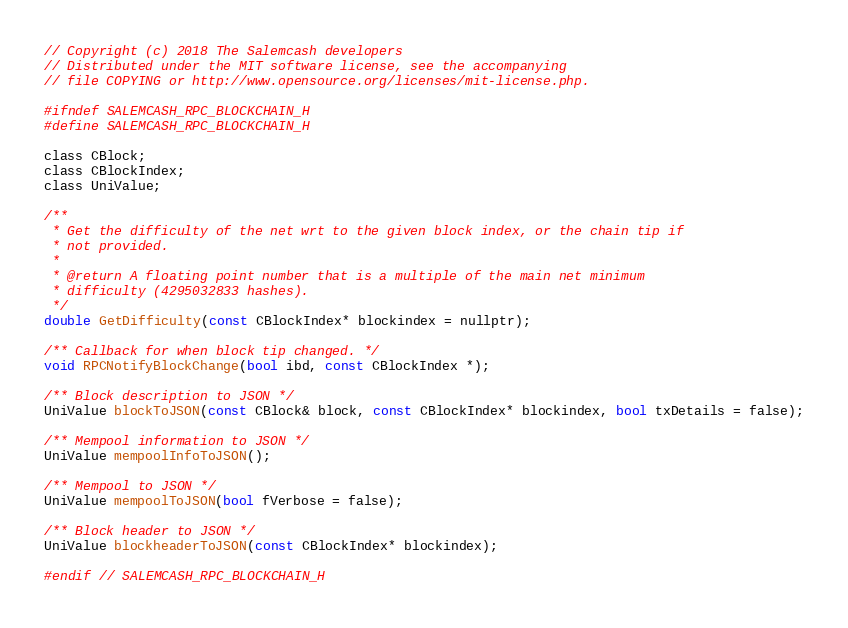Convert code to text. <code><loc_0><loc_0><loc_500><loc_500><_C_>// Copyright (c) 2018 The Salemcash developers
// Distributed under the MIT software license, see the accompanying
// file COPYING or http://www.opensource.org/licenses/mit-license.php.

#ifndef SALEMCASH_RPC_BLOCKCHAIN_H
#define SALEMCASH_RPC_BLOCKCHAIN_H

class CBlock;
class CBlockIndex;
class UniValue;

/**
 * Get the difficulty of the net wrt to the given block index, or the chain tip if
 * not provided.
 *
 * @return A floating point number that is a multiple of the main net minimum
 * difficulty (4295032833 hashes).
 */
double GetDifficulty(const CBlockIndex* blockindex = nullptr);

/** Callback for when block tip changed. */
void RPCNotifyBlockChange(bool ibd, const CBlockIndex *);

/** Block description to JSON */
UniValue blockToJSON(const CBlock& block, const CBlockIndex* blockindex, bool txDetails = false);

/** Mempool information to JSON */
UniValue mempoolInfoToJSON();

/** Mempool to JSON */
UniValue mempoolToJSON(bool fVerbose = false);

/** Block header to JSON */
UniValue blockheaderToJSON(const CBlockIndex* blockindex);

#endif // SALEMCASH_RPC_BLOCKCHAIN_H

</code> 